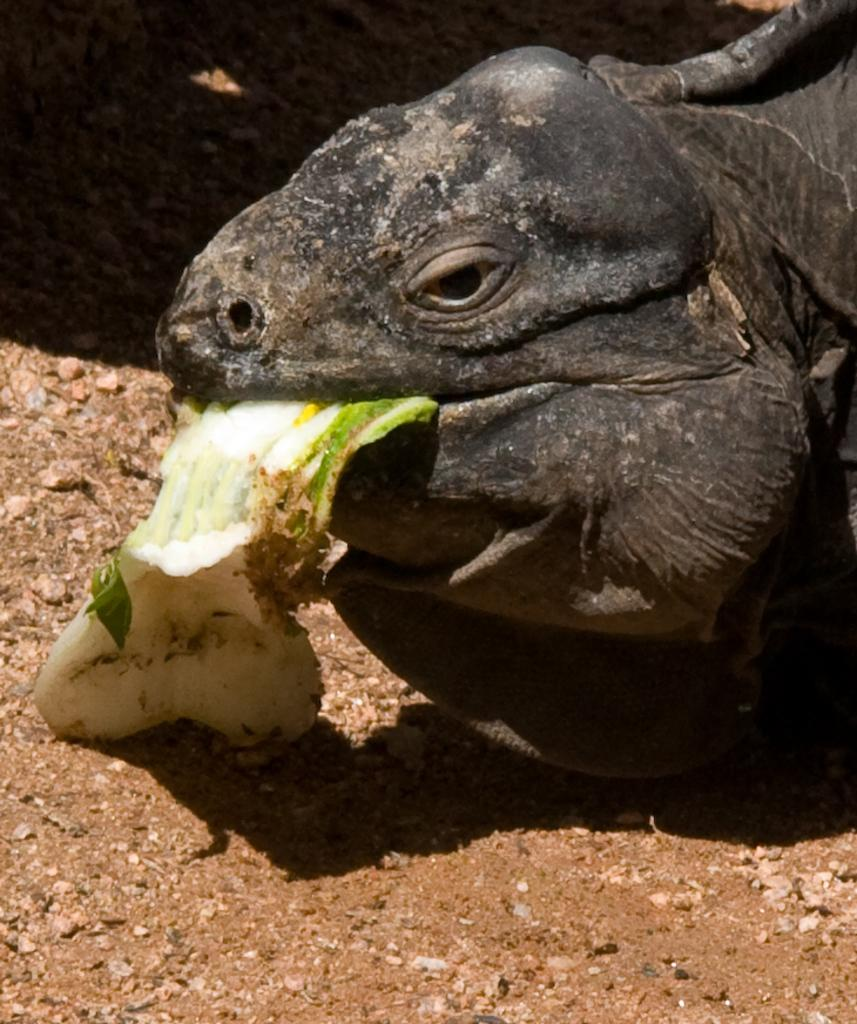What type of animal is in the image? There is a dragon lizard in the image. What is the dragon lizard doing in the image? The dragon lizard is having food. What can be seen at the bottom of the image? There is mud at the bottom of the image. What type of plate is the dragon lizard using to eat its food? There is no plate present in the image; the dragon lizard is having food without a plate. 